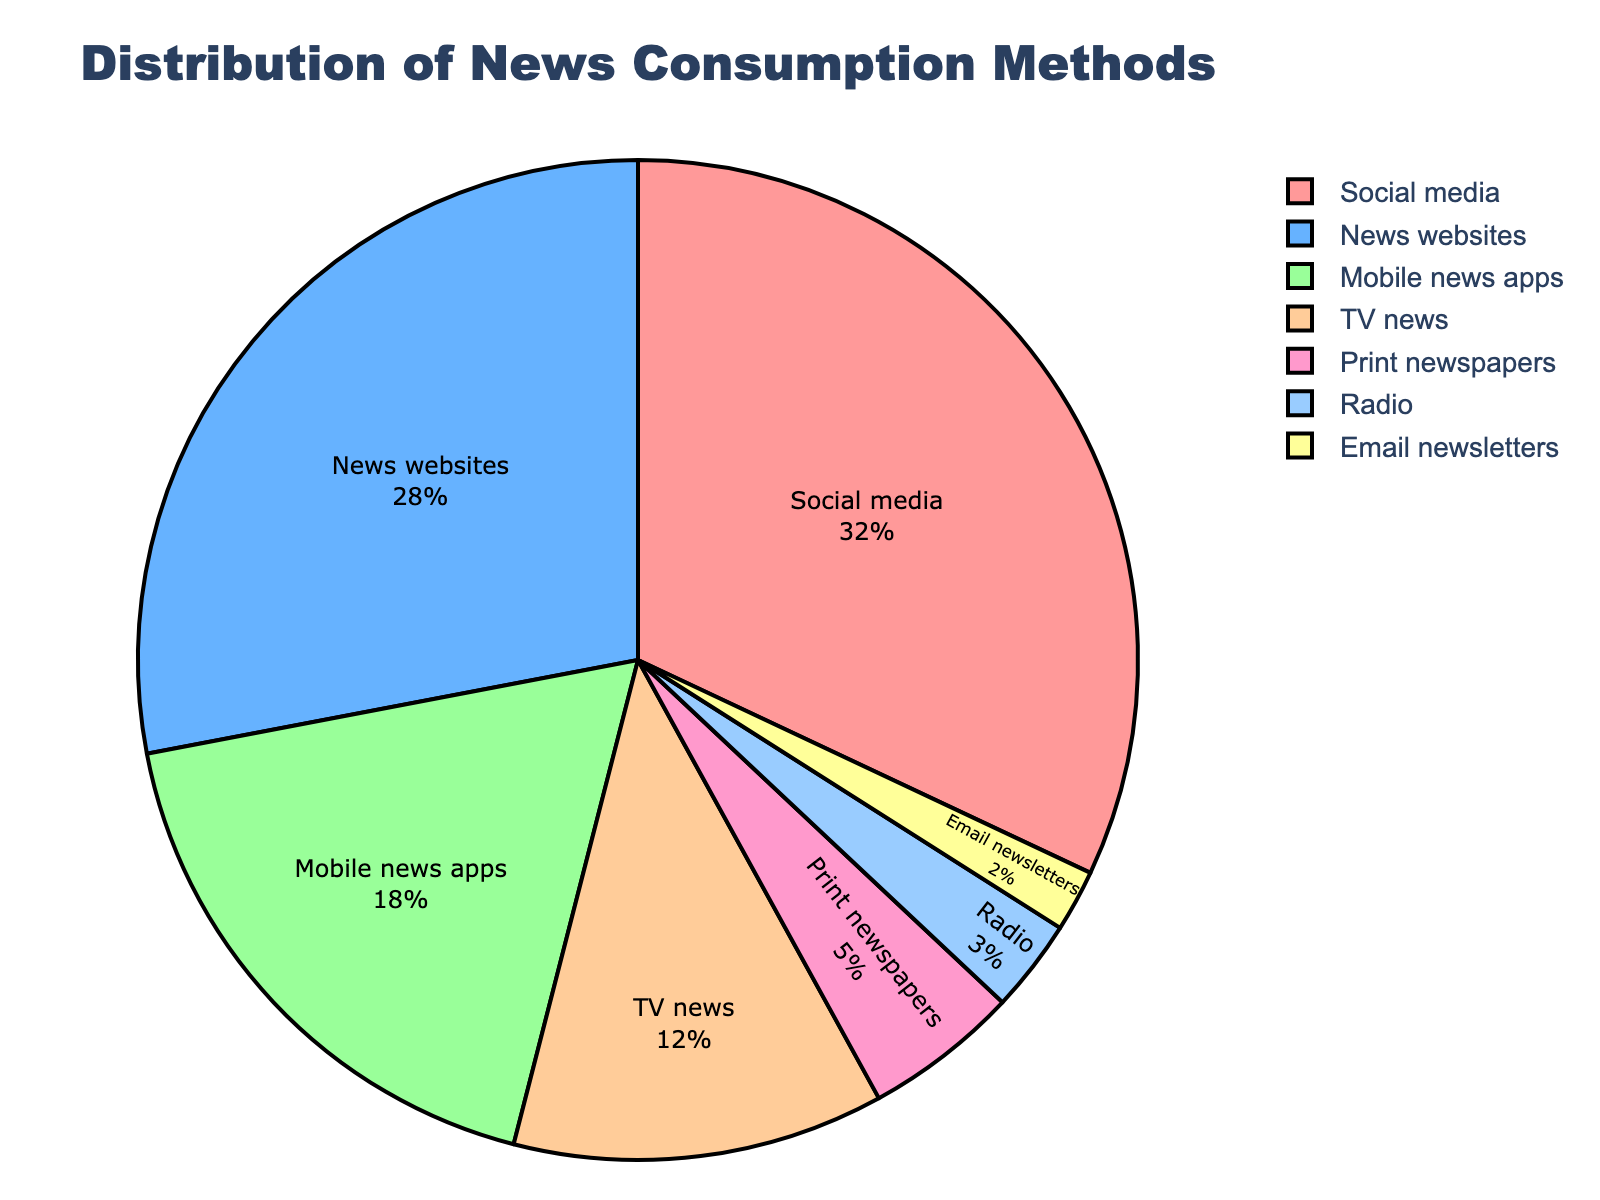What's the most popular method of news consumption? The figure shows that the segment for "Social media" occupies the largest portion of the pie chart at 32%.
Answer: Social media Which two methods combined account for more than half of the news consumption? The figure shows "Social media" at 32% and "News websites" at 28%. Adding these together, 32% + 28% = 60%, which is more than half.
Answer: Social media and News websites How does the percentage of people using TV news compare to those using print newspapers? The figure shows "TV news" at 12% and "Print newspapers" at 5%. 12% is greater than 5%.
Answer: TV news is greater Which news consumption method has the smallest percentage? The figure shows that "Email newsletters" occupies the smallest segment at 2%.
Answer: Email newsletters What is the combined percentage of news consumption via TV news and radio? The figure indicates "TV news" is 12% and "Radio" is 3%. Adding these together, 12% + 3% = 15%.
Answer: 15% If you combined the percentages of news consumption methods other than social media, what is the total? Subtract the social media percentage from 100%: 100% - 32% = 68%.
Answer: 68% How does the consumption percentage of mobile news apps compare to radio? The figure shows "Mobile news apps" at 18% and "Radio" at 3%. 18% is greater than 3%.
Answer: Mobile news apps are greater Identify the methods that each comprise less than 10% of the total news consumption. The figure shows "Print newspapers" at 5%, "Radio" at 3%, and "Email newsletters" at 2%, all of which are less than 10%.
Answer: Print newspapers, Radio, and Email newsletters What color represents the segment with the highest percentage of news consumption? The segment for "Social media," which has the highest percentage at 32%, is colored red.
Answer: Red 